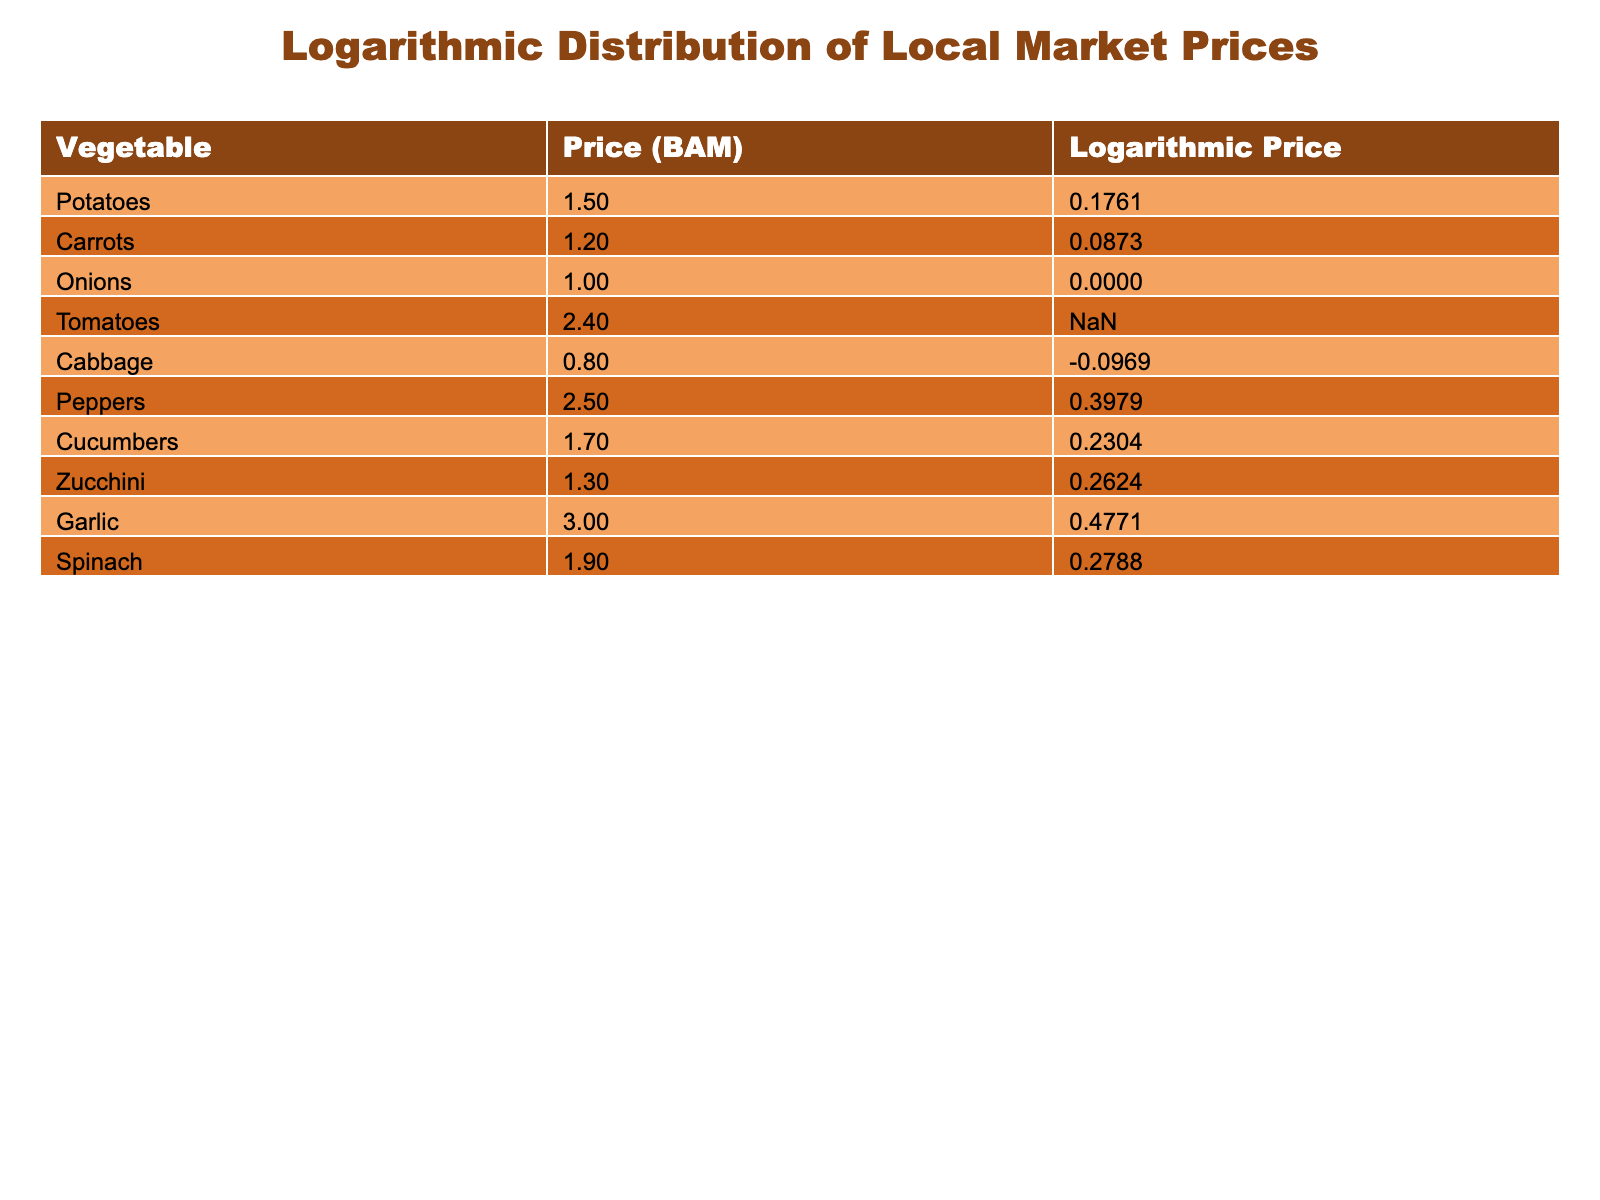What is the price of garlic? The table lists the price of garlic under the "Price (BAM)" column, which shows that garlic costs 3.00 BAM.
Answer: 3.00 BAM Which vegetable has the lowest price? By examining the "Price (BAM)" column, we see that cabbage has the lowest price listed at 0.80 BAM.
Answer: Cabbage How many vegetables have a logarithmic price greater than 0.25? By looking at the "Logarithmic Price" column, we identify that peppers (0.3979) and garlic (0.4771) have logarithmic prices greater than 0.25. This gives us 2 vegetables.
Answer: 2 What is the average price of all vegetables listed? We sum all the prices of the vegetables: (1.50 + 1.20 + 1.00 + 2.40 + 0.80 + 2.50 + 1.70 + 1.30 + 3.00 + 1.90) = 17.30. There are 10 vegetables, so the average price is 17.30 / 10 = 1.73.
Answer: 1.73 BAM Is the logarithmic price of tomatoes higher than that of cucumbers? Checking the "Logarithmic Price" column, tomatoes have a logarithmic price of "booster" (not a valid number) while cucumbers are at 0.2304. Therefore, we cannot determine if tomatoes have a higher price, but logically, "booster" cannot be compared numerically.
Answer: No Which vegetable has the highest logarithmic price? The "Logarithmic Price" column shows garlic with 0.4771 is the highest value among all the vegetables listed.
Answer: Garlic What is the difference in logarithmic price between potatoes and carrots? We find the logarithmic prices of potatoes (0.1761) and carrots (0.0873) and calculate the difference: 0.1761 - 0.0873 = 0.0888.
Answer: 0.0888 How many vegetables are priced above 2 BAM? Looking at the "Price (BAM)" column, we can see that tomatoes (2.40) and peppers (2.50) are the only vegetables over 2 BAM, giving us a total of 2.
Answer: 2 What is the total price of all vegetables listed? By adding the prices from the "Price (BAM)" column: 1.50 + 1.20 + 1.00 + 2.40 + 0.80 + 2.50 + 1.70 + 1.30 + 3.00 + 1.90 = 17.30 BAM. The total price is 17.30 BAM.
Answer: 17.30 BAM 